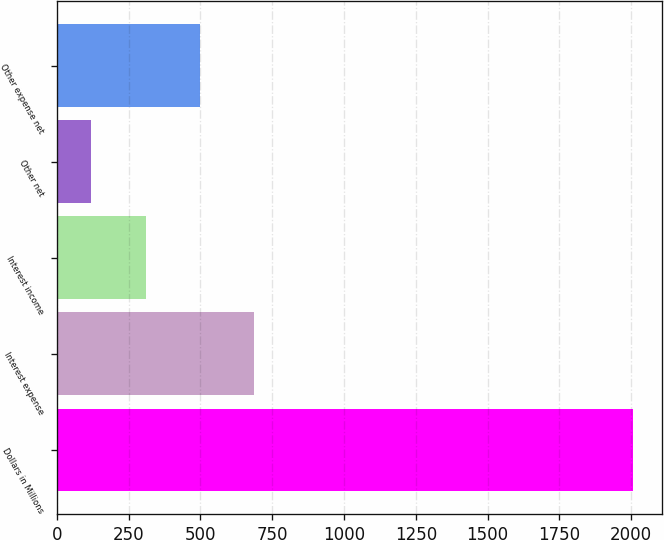Convert chart to OTSL. <chart><loc_0><loc_0><loc_500><loc_500><bar_chart><fcel>Dollars in Millions<fcel>Interest expense<fcel>Interest income<fcel>Other net<fcel>Other expense net<nl><fcel>2007<fcel>686.1<fcel>308.7<fcel>120<fcel>497.4<nl></chart> 